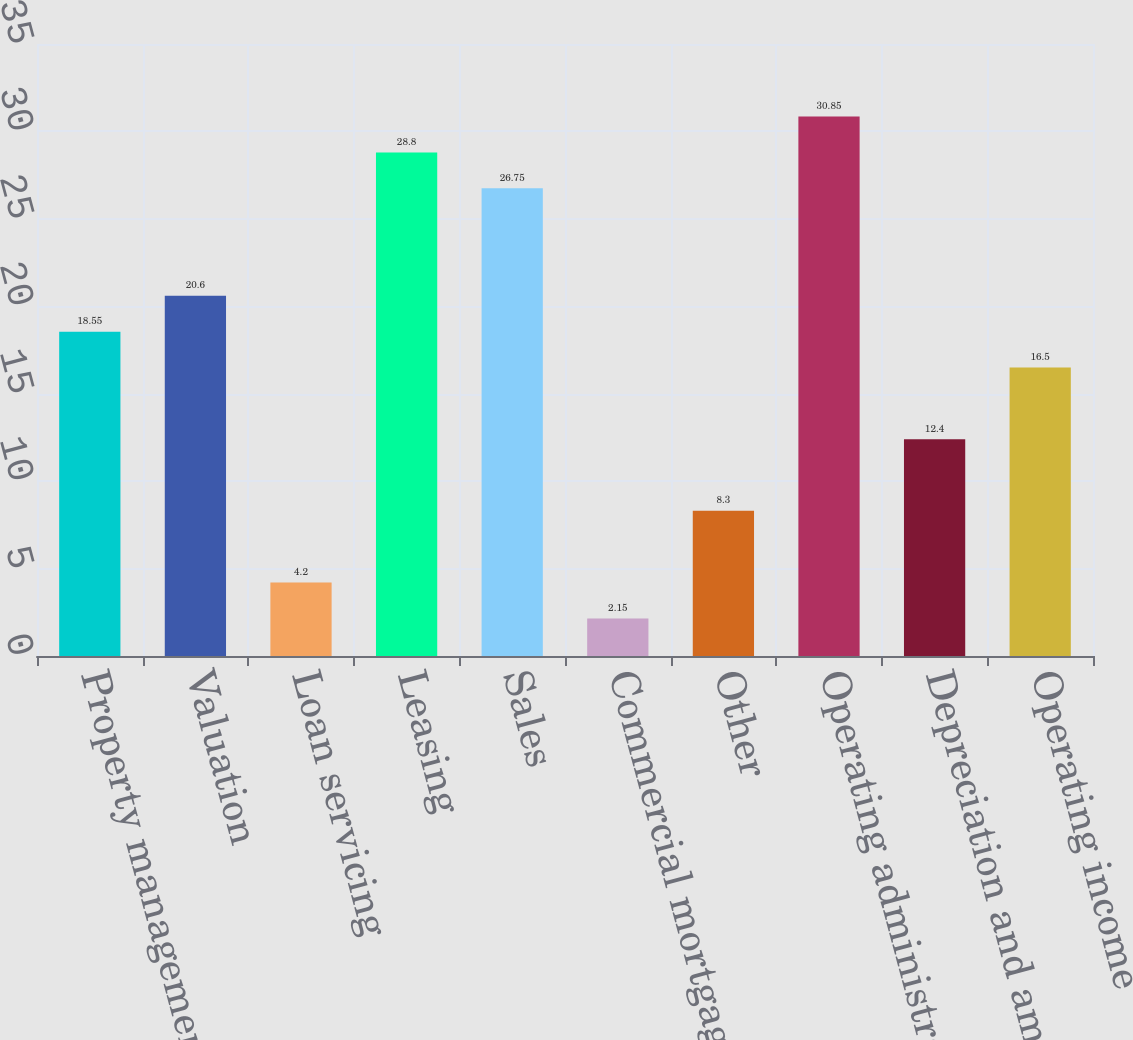Convert chart to OTSL. <chart><loc_0><loc_0><loc_500><loc_500><bar_chart><fcel>Property management<fcel>Valuation<fcel>Loan servicing<fcel>Leasing<fcel>Sales<fcel>Commercial mortgage<fcel>Other<fcel>Operating administrative and<fcel>Depreciation and amortization<fcel>Operating income<nl><fcel>18.55<fcel>20.6<fcel>4.2<fcel>28.8<fcel>26.75<fcel>2.15<fcel>8.3<fcel>30.85<fcel>12.4<fcel>16.5<nl></chart> 